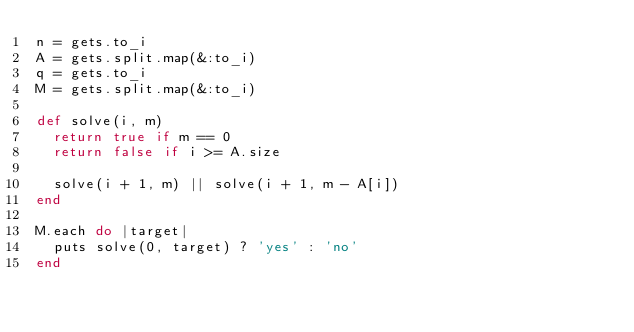Convert code to text. <code><loc_0><loc_0><loc_500><loc_500><_Ruby_>n = gets.to_i
A = gets.split.map(&:to_i)
q = gets.to_i
M = gets.split.map(&:to_i)

def solve(i, m)
  return true if m == 0
  return false if i >= A.size

  solve(i + 1, m) || solve(i + 1, m - A[i])
end

M.each do |target|
  puts solve(0, target) ? 'yes' : 'no'
end</code> 